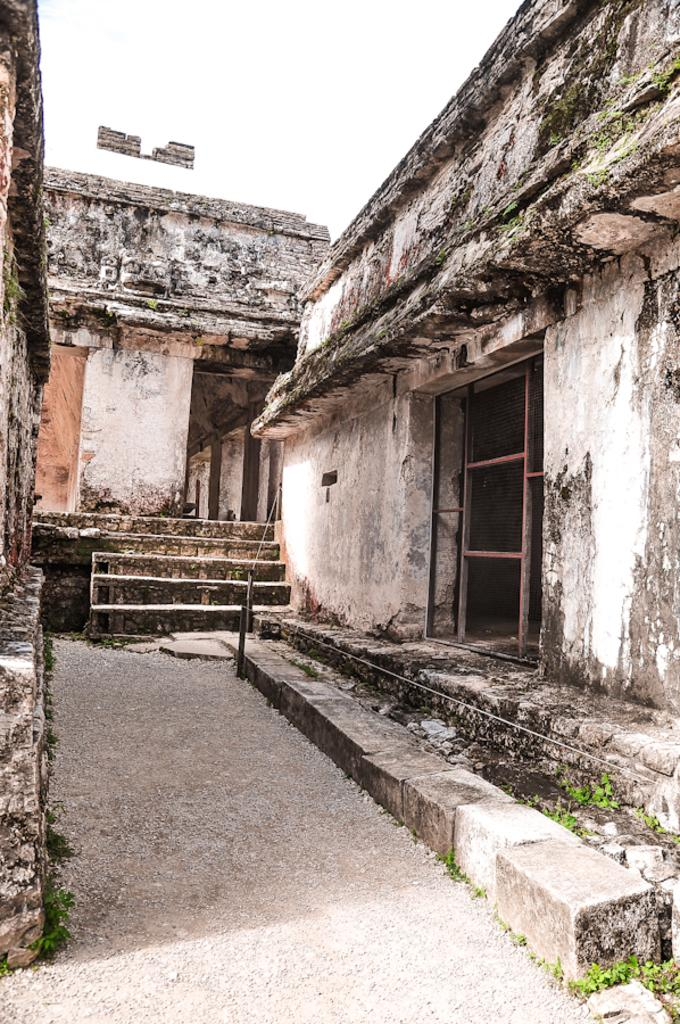What type of structures can be seen in the image? There are houses in the image. What architectural feature is present in the image? There are steps in the image. What type of vegetation is visible in the image? There are plants in the image. What part of the natural environment is visible in the image? The sky is visible in the image. What type of seat can be seen in the image? There is no seat present in the image. What type of drug is visible in the image? There is no drug present in the image. 